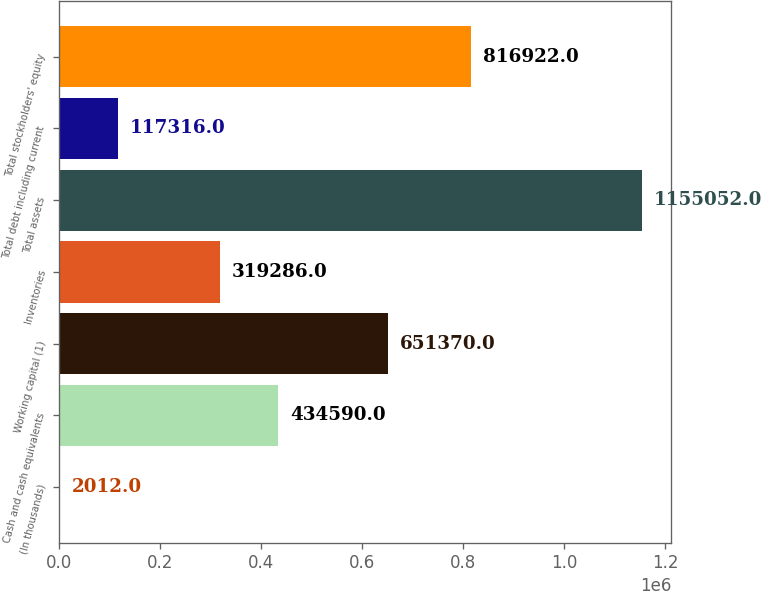<chart> <loc_0><loc_0><loc_500><loc_500><bar_chart><fcel>(In thousands)<fcel>Cash and cash equivalents<fcel>Working capital (1)<fcel>Inventories<fcel>Total assets<fcel>Total debt including current<fcel>Total stockholders' equity<nl><fcel>2012<fcel>434590<fcel>651370<fcel>319286<fcel>1.15505e+06<fcel>117316<fcel>816922<nl></chart> 